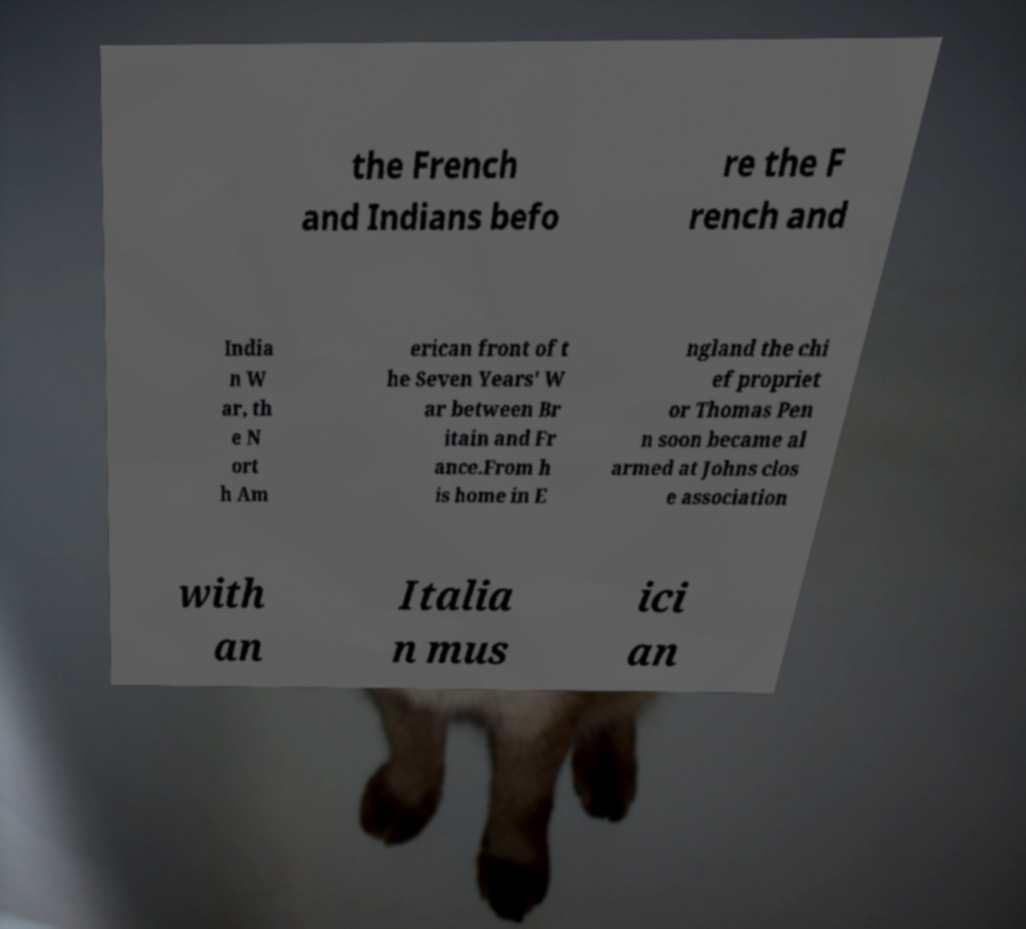Can you read and provide the text displayed in the image?This photo seems to have some interesting text. Can you extract and type it out for me? the French and Indians befo re the F rench and India n W ar, th e N ort h Am erican front of t he Seven Years' W ar between Br itain and Fr ance.From h is home in E ngland the chi ef propriet or Thomas Pen n soon became al armed at Johns clos e association with an Italia n mus ici an 